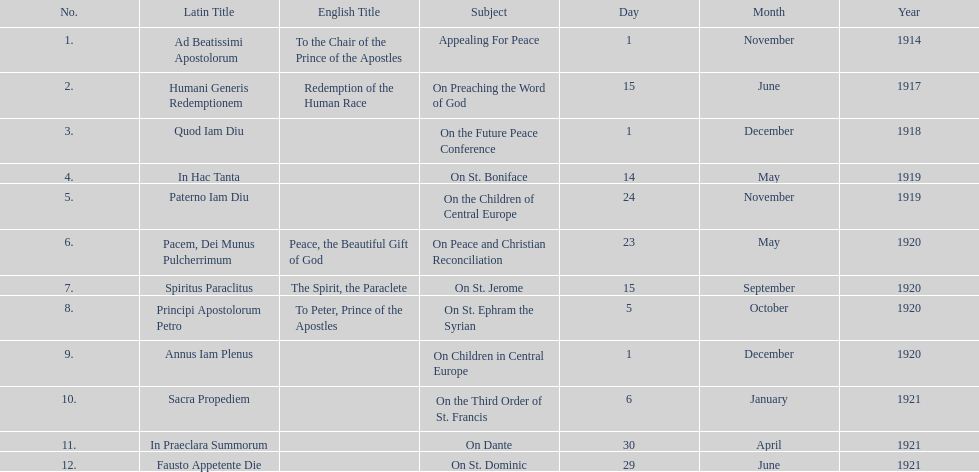How long after quod iam diu was paterno iam diu issued? 11 months. 